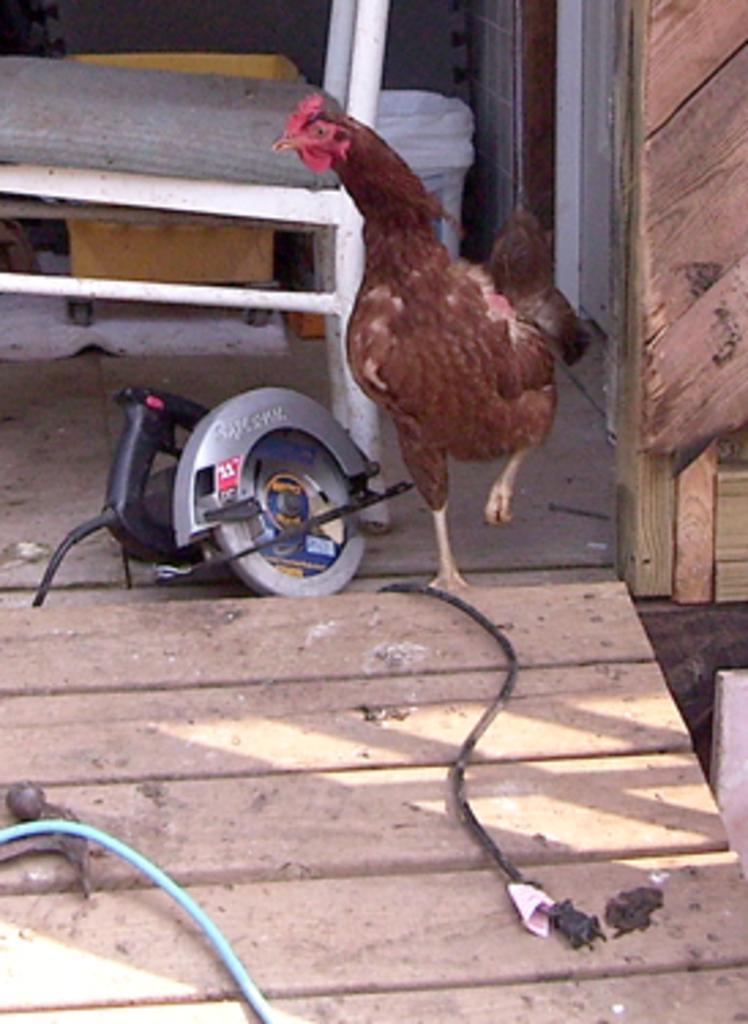How would you summarize this image in a sentence or two? In this picture we can see brown hen in the front. Beside there is a wooden cutting machine. Behind there is a white chair. In the front bottom side we can see the wooden board. 